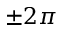Convert formula to latex. <formula><loc_0><loc_0><loc_500><loc_500>\pm 2 \pi</formula> 